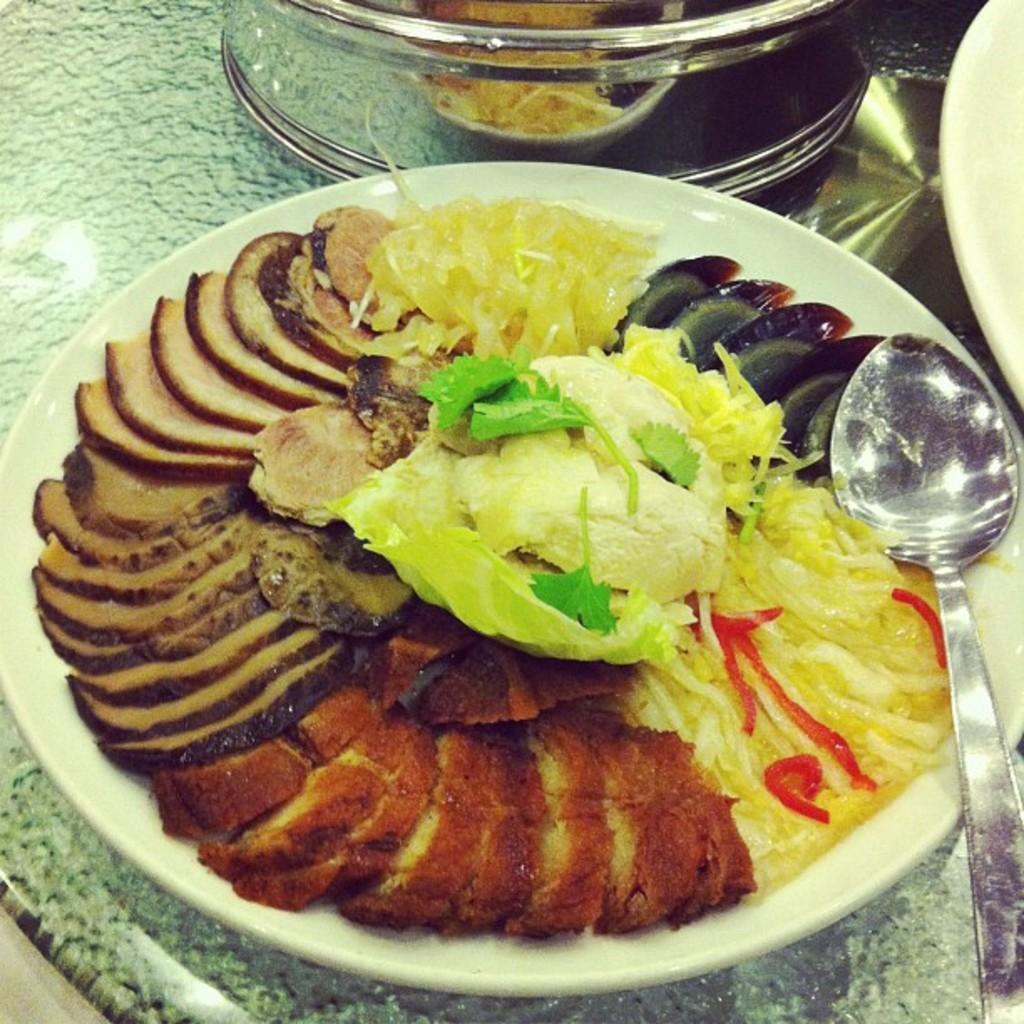How would you summarize this image in a sentence or two? It is a zoomed in picture of food items present in a white plate. We can also a spoon and also a glass vessel on the surface. 